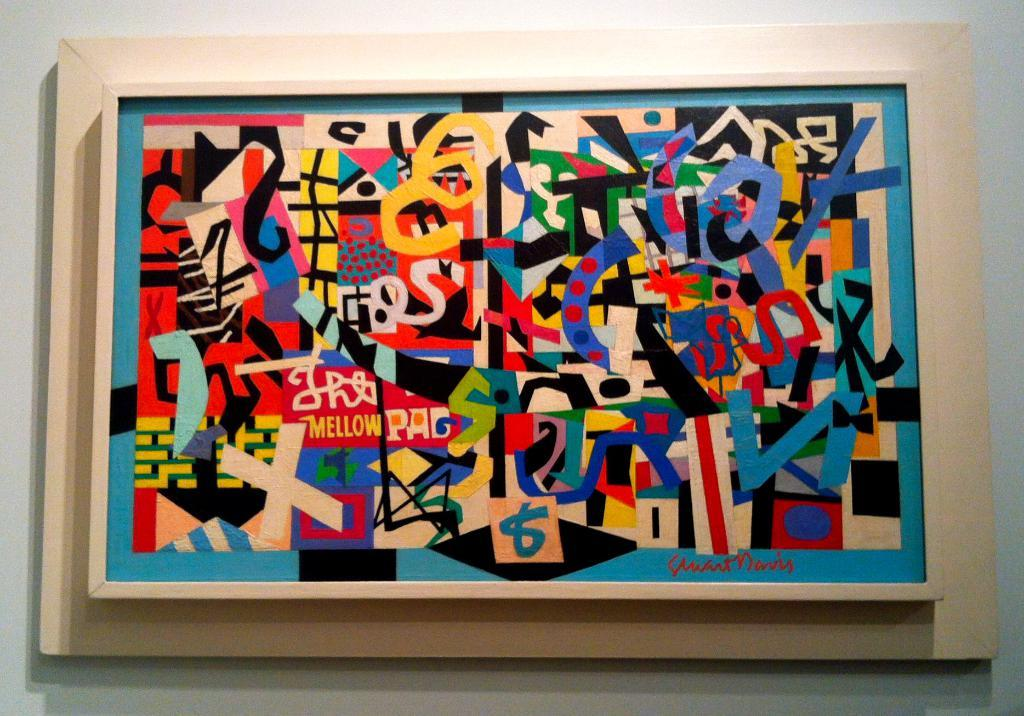<image>
Render a clear and concise summary of the photo. A very busy painting contains the legible word mellow. 